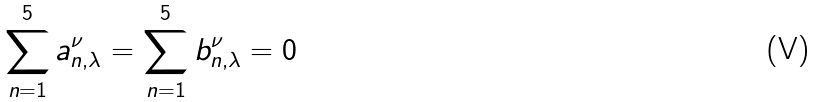Convert formula to latex. <formula><loc_0><loc_0><loc_500><loc_500>\sum _ { n = 1 } ^ { 5 } a ^ { \nu } _ { n , \lambda } = \sum _ { n = 1 } ^ { 5 } b ^ { \nu } _ { n , \lambda } = 0</formula> 